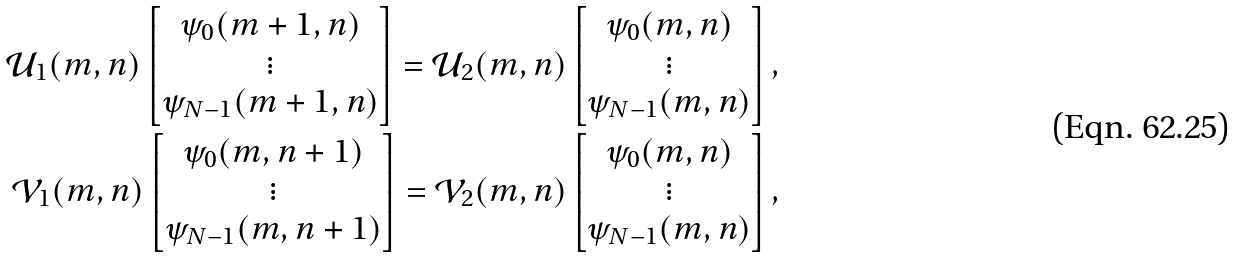Convert formula to latex. <formula><loc_0><loc_0><loc_500><loc_500>\mathcal { U } _ { 1 } ( m , n ) \begin{bmatrix} \psi _ { 0 } ( m + 1 , n ) \\ \vdots \\ \psi _ { N - 1 } ( m + 1 , n ) \end{bmatrix} = \mathcal { U } _ { 2 } ( m , n ) \begin{bmatrix} \psi _ { 0 } ( m , n ) \\ \vdots \\ \psi _ { N - 1 } ( m , n ) \end{bmatrix} , \\ \mathcal { V } _ { 1 } ( m , n ) \begin{bmatrix} \psi _ { 0 } ( m , n + 1 ) \\ \vdots \\ \psi _ { N - 1 } ( m , n + 1 ) \end{bmatrix} = \mathcal { V } _ { 2 } ( m , n ) \begin{bmatrix} \psi _ { 0 } ( m , n ) \\ \vdots \\ \psi _ { N - 1 } ( m , n ) \end{bmatrix} ,</formula> 